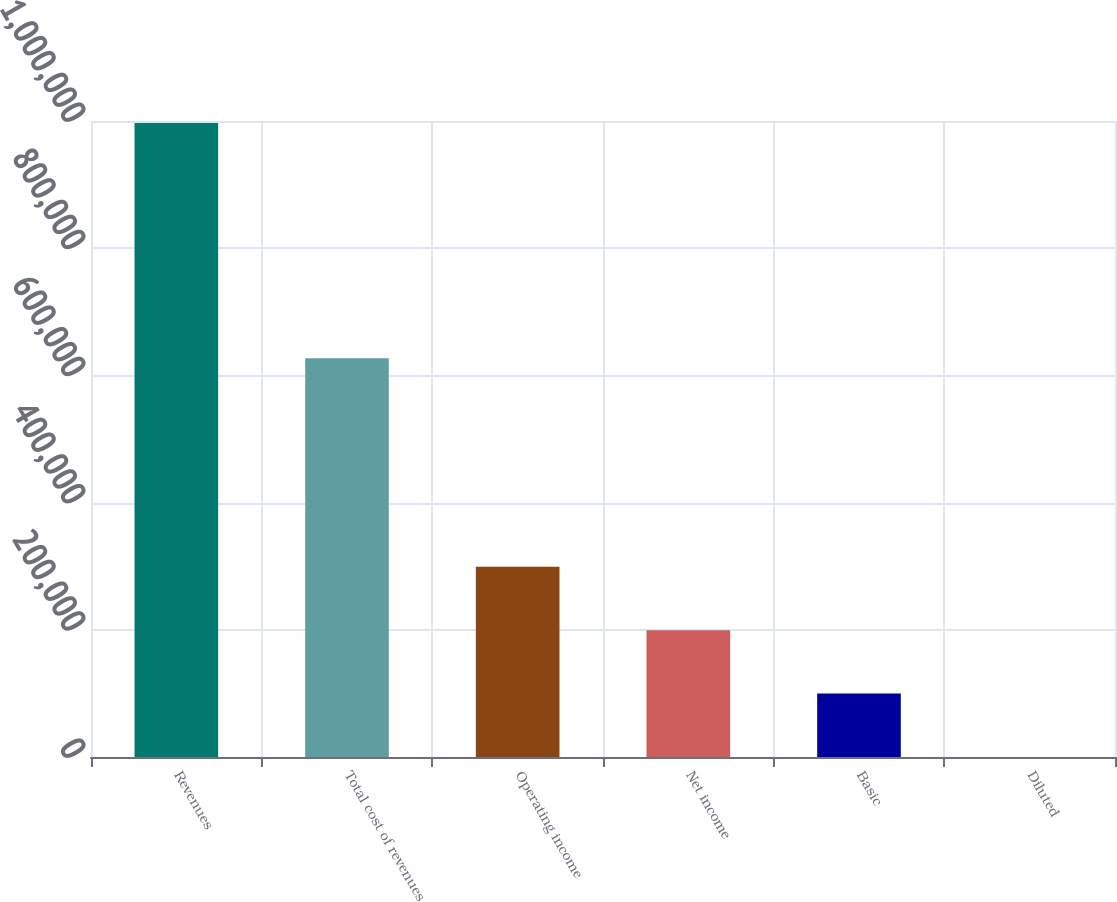Convert chart. <chart><loc_0><loc_0><loc_500><loc_500><bar_chart><fcel>Revenues<fcel>Total cost of revenues<fcel>Operating income<fcel>Net income<fcel>Basic<fcel>Diluted<nl><fcel>996660<fcel>626985<fcel>298998<fcel>199333<fcel>99666.6<fcel>0.71<nl></chart> 